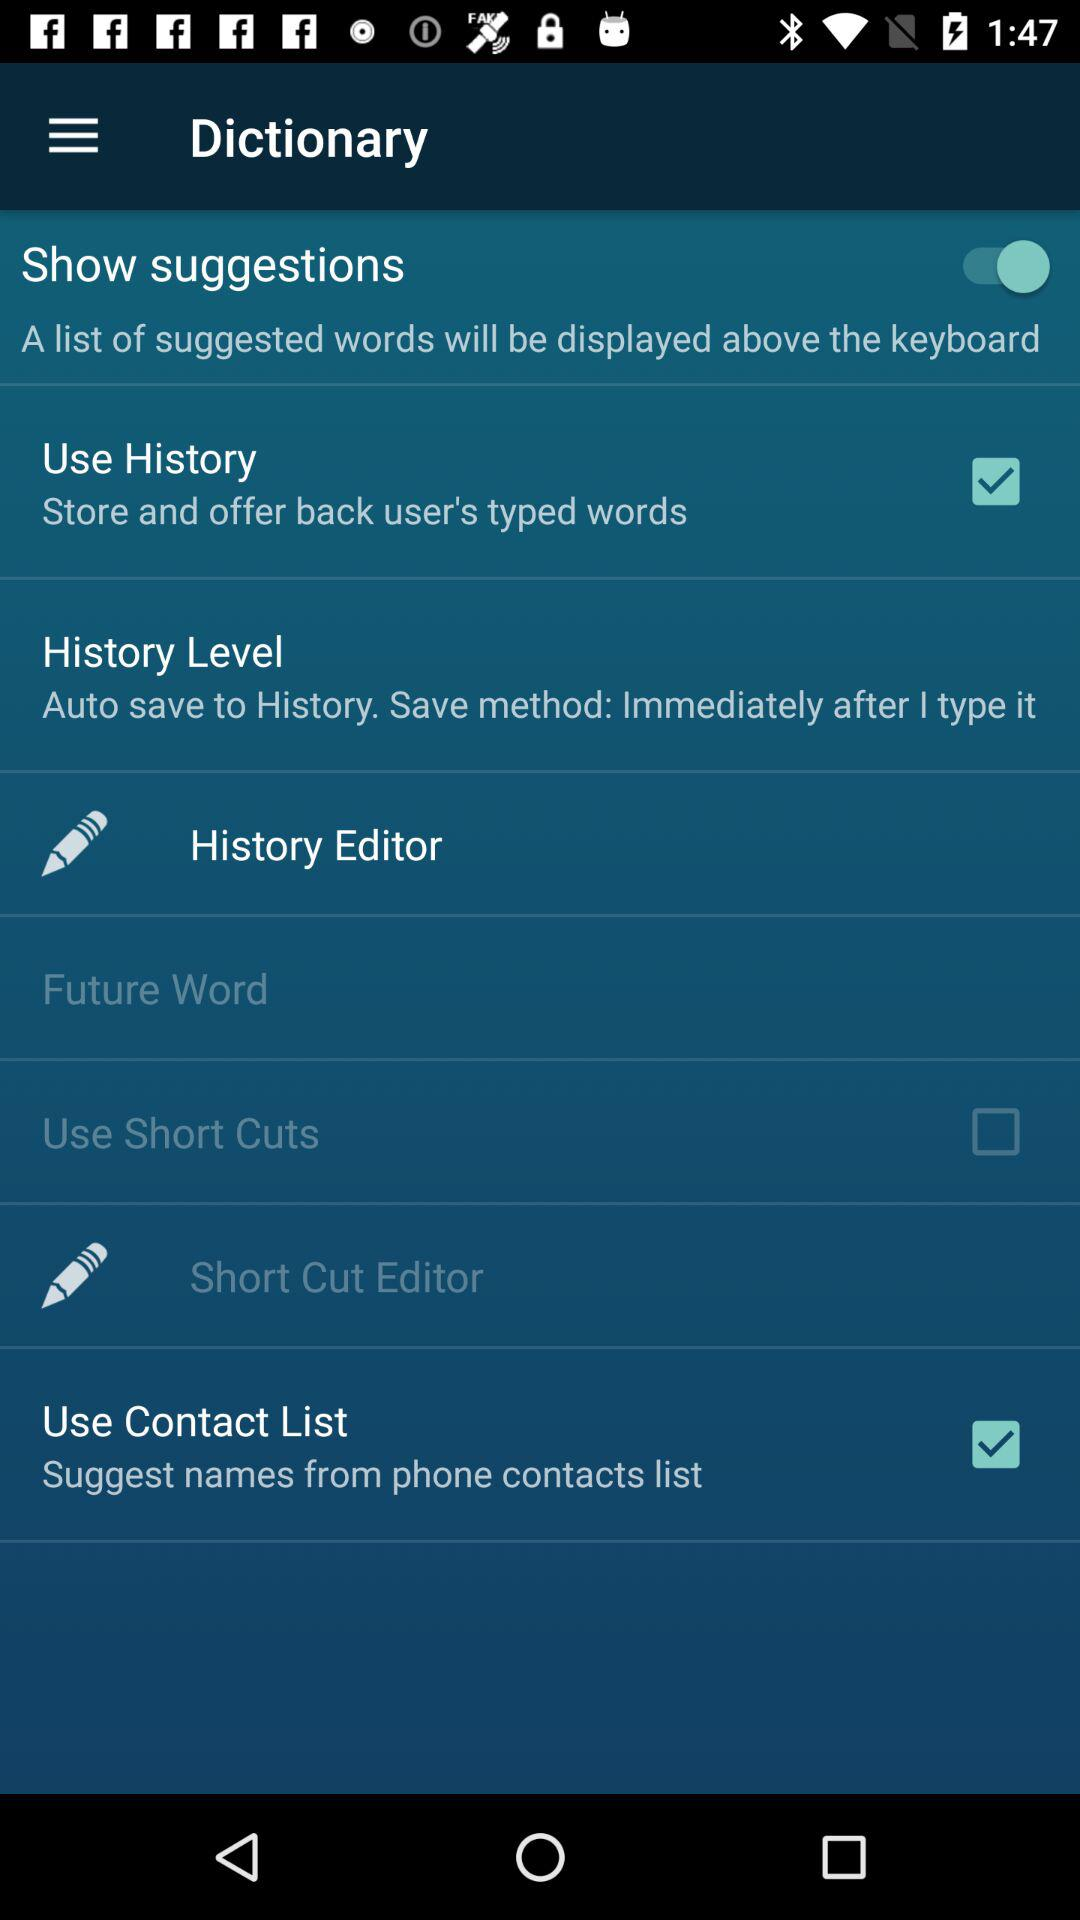What is the status of the "Show suggestions" setting? The status is "on". 